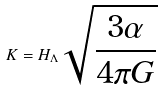<formula> <loc_0><loc_0><loc_500><loc_500>K = H _ { \Lambda } \sqrt { \frac { 3 \alpha } { 4 \pi G } }</formula> 